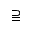<formula> <loc_0><loc_0><loc_500><loc_500>\supseteqq</formula> 